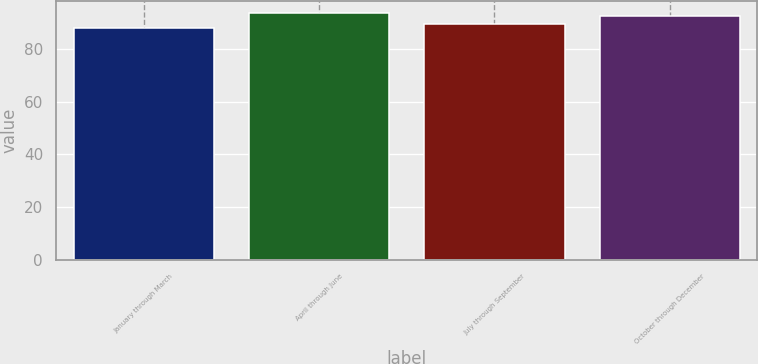<chart> <loc_0><loc_0><loc_500><loc_500><bar_chart><fcel>January through March<fcel>April through June<fcel>July through September<fcel>October through December<nl><fcel>87.91<fcel>93.59<fcel>89.29<fcel>92.37<nl></chart> 